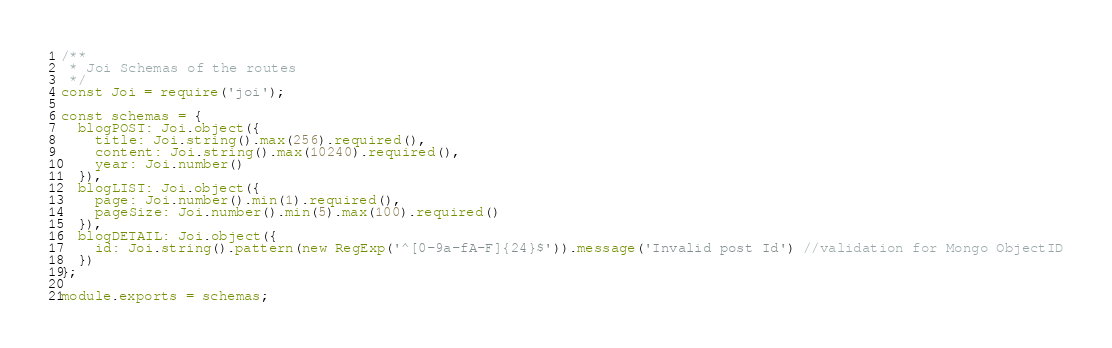<code> <loc_0><loc_0><loc_500><loc_500><_JavaScript_>/**
 * Joi Schemas of the routes
 */
const Joi = require('joi');

const schemas = {
  blogPOST: Joi.object({
    title: Joi.string().max(256).required(),
    content: Joi.string().max(10240).required(),
    year: Joi.number()
  }),
  blogLIST: Joi.object({
    page: Joi.number().min(1).required(),
    pageSize: Joi.number().min(5).max(100).required()
  }),
  blogDETAIL: Joi.object({
    id: Joi.string().pattern(new RegExp('^[0-9a-fA-F]{24}$')).message('Invalid post Id') //validation for Mongo ObjectID
  })
};

module.exports = schemas;</code> 